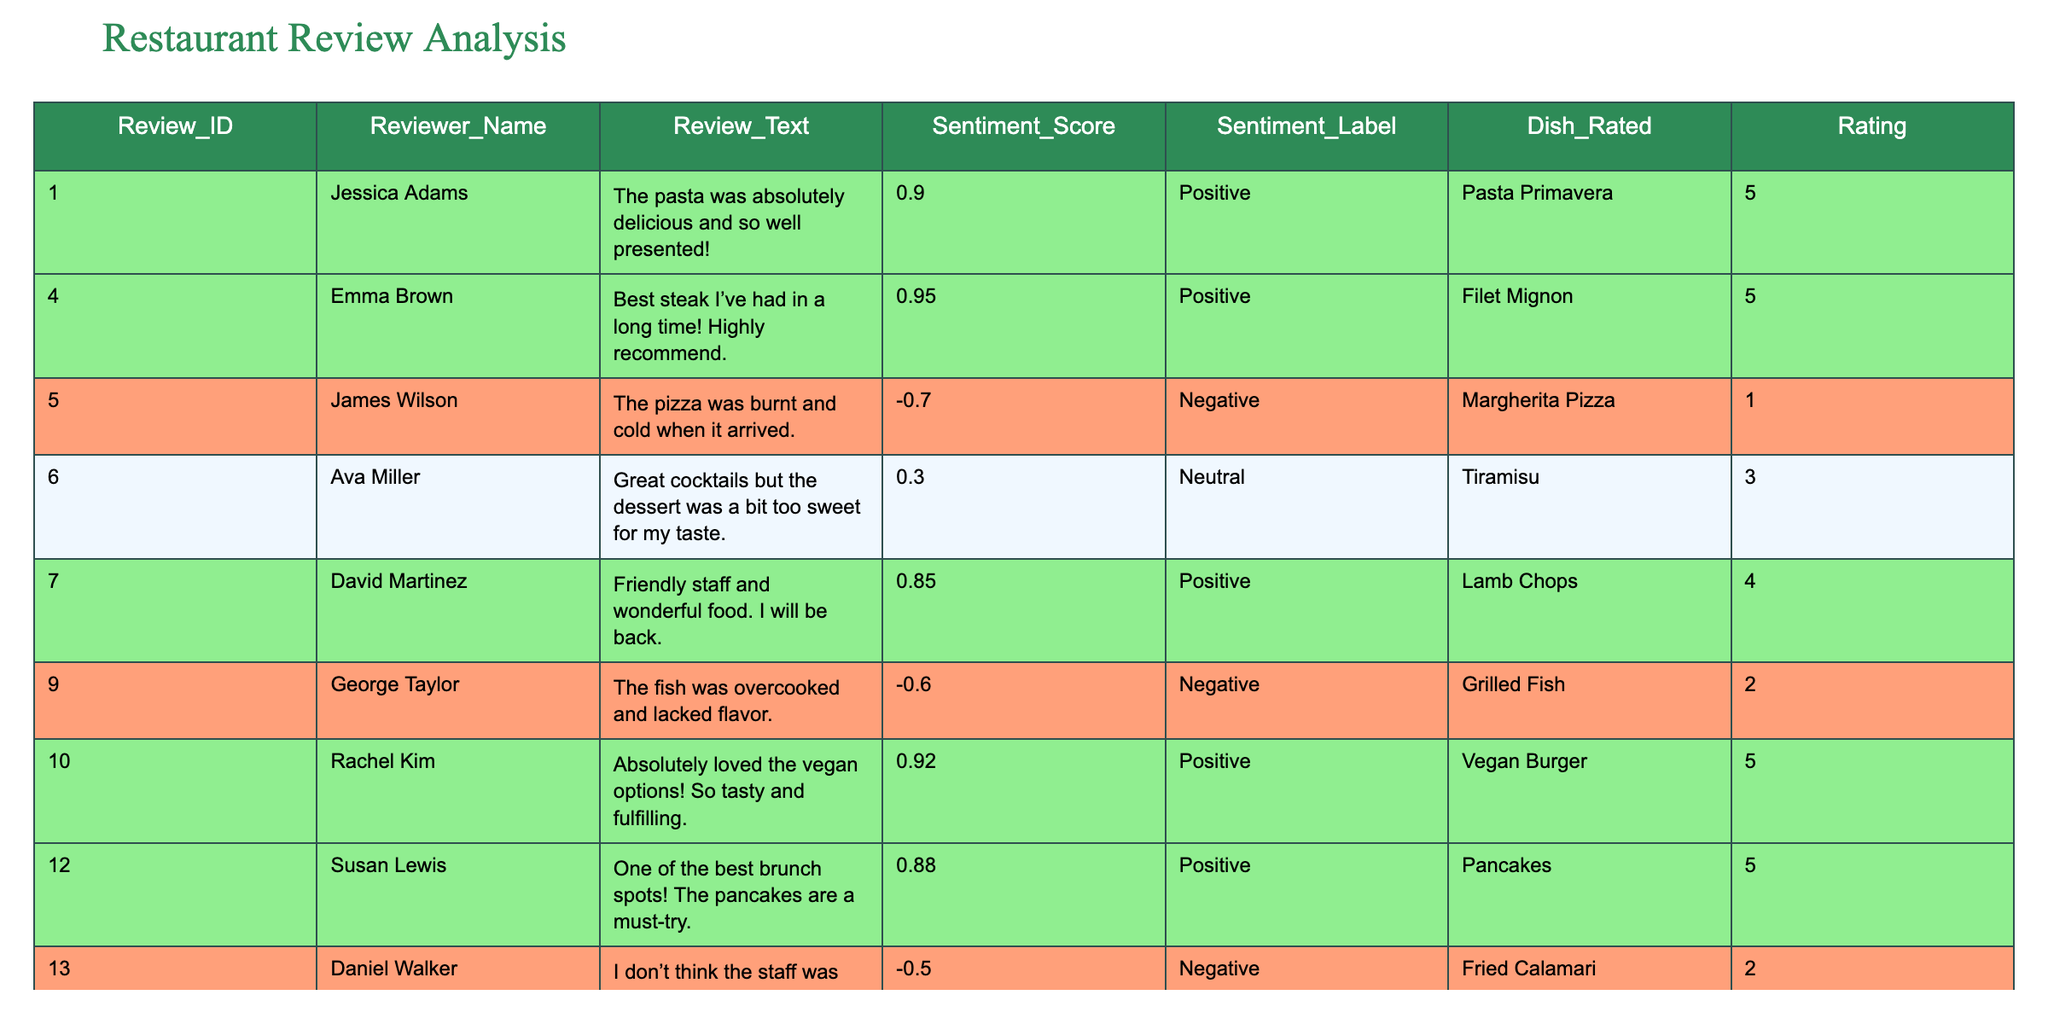What is the sentiment label for the review with ID 5? The review with ID 5 belongs to James Wilson, who rated the Margherita Pizza with a sentiment of negative. This can be found directly in the Sentiment_Label column for that review ID.
Answer: Negative Which dish received the highest rating according to the reviews? The highest rating recorded in the table is 5, which is given to multiple dishes: Pasta Primavera, Filet Mignon, Vegan Burger, Pancakes, and Seafood Platter. All of these dishes share the same highest score.
Answer: Pasta Primavera, Filet Mignon, Vegan Burger, Pancakes, Seafood Platter What is the average sentiment score of all the reviews? The sentiment scores from the reviews are: 0.9, 0.95, -0.7, 0.3, 0.85, -0.6, 0.92, 0.88, -0.5, 0.4, and 0.95. Adding these gives a total of 3.6. There are 11 scores, so 3.6 divided by 11 equals approximately 0.327.
Answer: 0.327 Did any reviews mention a negative experience with dessert? Daniel Walker's review indicates a lack of attentiveness from staff during his Fried Calamari order, and Nancy Robinson states the dessert could improve, which implies dissatisfaction. Therefore, yes, there are negative mentions about dessert in reviews.
Answer: Yes How many reviews were rated neutral? The neutral reviews in the table are those with a sentiment label of 'Neutral': Ava Miller's review (Tiramisu) and Nancy Robinson's review (Chocolate Lava Cake). Counting these reviews gives a total of 2 neutral ratings.
Answer: 2 What is the difference between the highest and lowest rating given in the reviews? The highest rating is 5 and the lowest is 1. Calculating the difference gives 5 - 1 = 4. Therefore, the difference between the highest and lowest rating is 4.
Answer: 4 List the reviewers who had a positive sentiment towards their dining experience. The reviewers with a positive sentiment label are Jessica Adams, Emma Brown, David Martinez, Rachel Kim, Susan Lewis, and Andrew Thompson. Their reviews reflect positive experiences based on their sentiments.
Answer: Jessica Adams, Emma Brown, David Martinez, Rachel Kim, Susan Lewis, Andrew Thompson What percentage of the reviews are classified as negative? There are 11 total reviews, of which 3 are negative: James Wilson, George Taylor, and Daniel Walker. To find the percentage, calculate (3/11) * 100, which gives approximately 27.27%.
Answer: 27.27% Is the review with the ID of 14 positive, negative, or neutral? Review ID 14 belongs to Nancy Robinson, who gave a neutral sentiment label. This is found in the Sentiment_Label column for ID 14, confirming its neutrality.
Answer: Neutral 